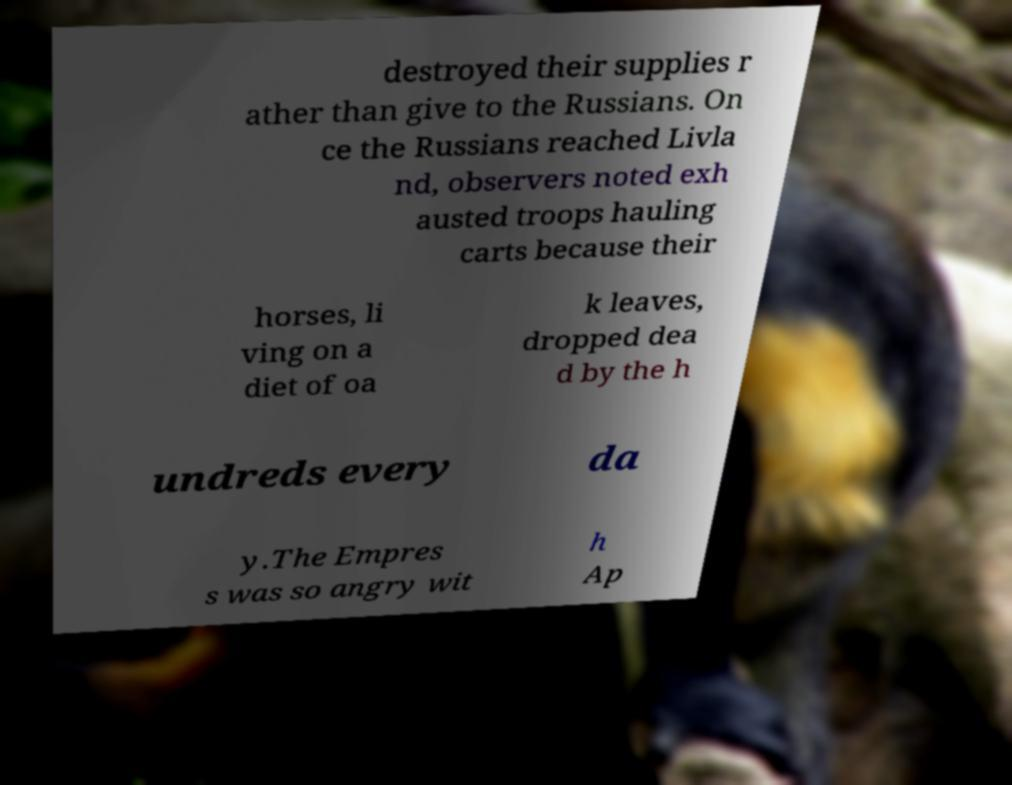I need the written content from this picture converted into text. Can you do that? destroyed their supplies r ather than give to the Russians. On ce the Russians reached Livla nd, observers noted exh austed troops hauling carts because their horses, li ving on a diet of oa k leaves, dropped dea d by the h undreds every da y.The Empres s was so angry wit h Ap 